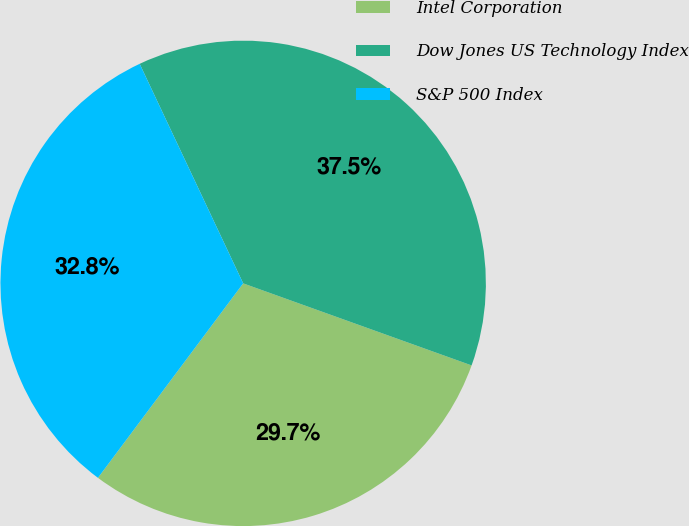Convert chart. <chart><loc_0><loc_0><loc_500><loc_500><pie_chart><fcel>Intel Corporation<fcel>Dow Jones US Technology Index<fcel>S&P 500 Index<nl><fcel>29.72%<fcel>37.5%<fcel>32.78%<nl></chart> 